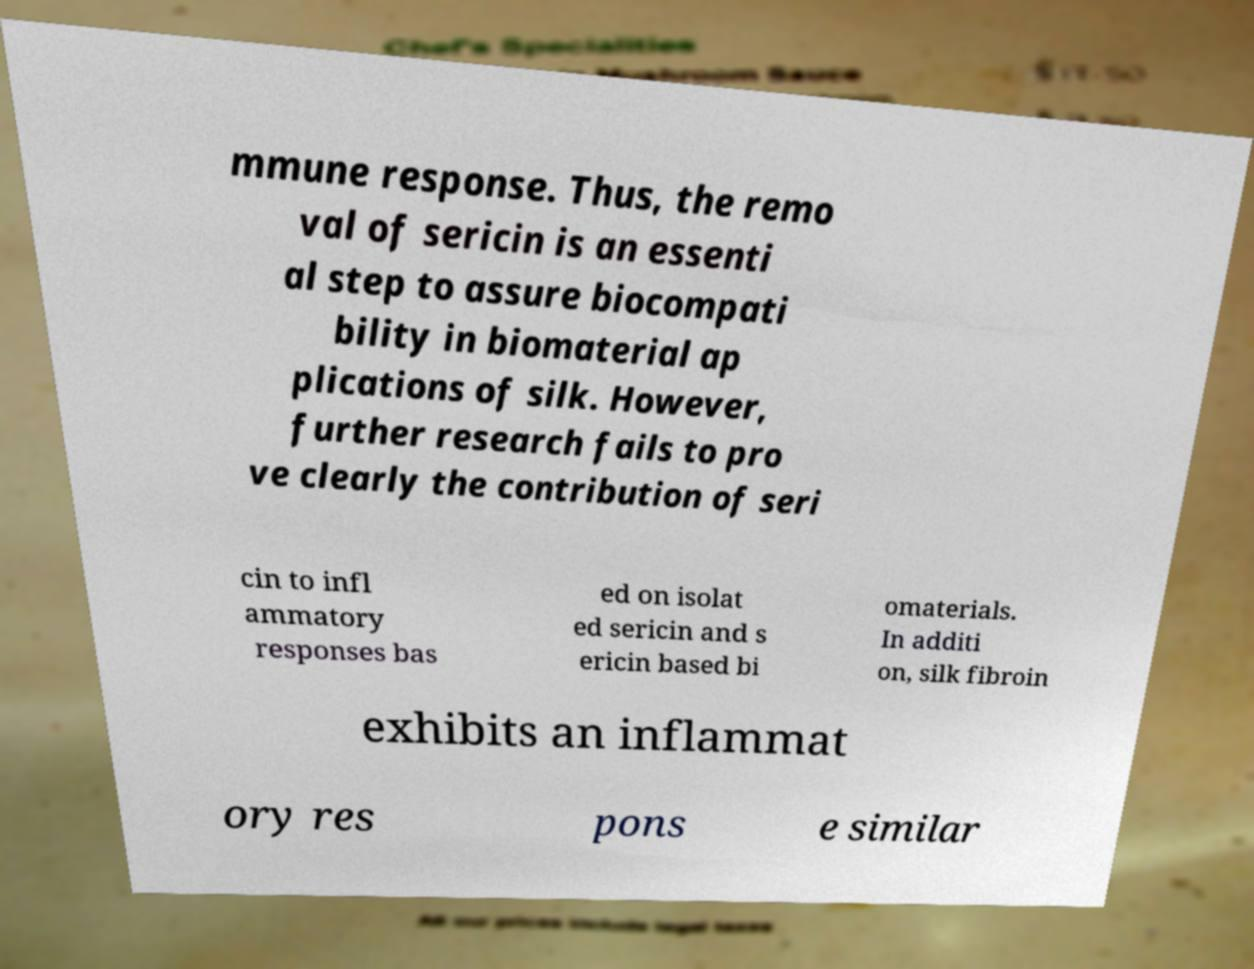What messages or text are displayed in this image? I need them in a readable, typed format. mmune response. Thus, the remo val of sericin is an essenti al step to assure biocompati bility in biomaterial ap plications of silk. However, further research fails to pro ve clearly the contribution of seri cin to infl ammatory responses bas ed on isolat ed sericin and s ericin based bi omaterials. In additi on, silk fibroin exhibits an inflammat ory res pons e similar 